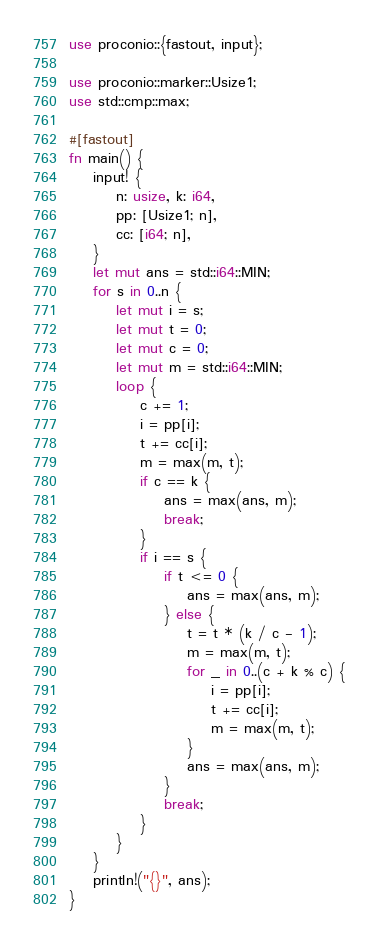Convert code to text. <code><loc_0><loc_0><loc_500><loc_500><_Rust_>use proconio::{fastout, input};

use proconio::marker::Usize1;
use std::cmp::max;

#[fastout]
fn main() {
    input! {
        n: usize, k: i64,
        pp: [Usize1; n],
        cc: [i64; n],
    }
    let mut ans = std::i64::MIN;
    for s in 0..n {
        let mut i = s;
        let mut t = 0;
        let mut c = 0;
        let mut m = std::i64::MIN;
        loop {
            c += 1;
            i = pp[i];
            t += cc[i];
            m = max(m, t);
            if c == k {
                ans = max(ans, m);
                break;
            }
            if i == s {
                if t <= 0 {
                    ans = max(ans, m);
                } else {
                    t = t * (k / c - 1);
                    m = max(m, t);
                    for _ in 0..(c + k % c) {
                        i = pp[i];
                        t += cc[i];
                        m = max(m, t);
                    }
                    ans = max(ans, m);
                }
                break;
            }
        }
    }
    println!("{}", ans);
}
</code> 